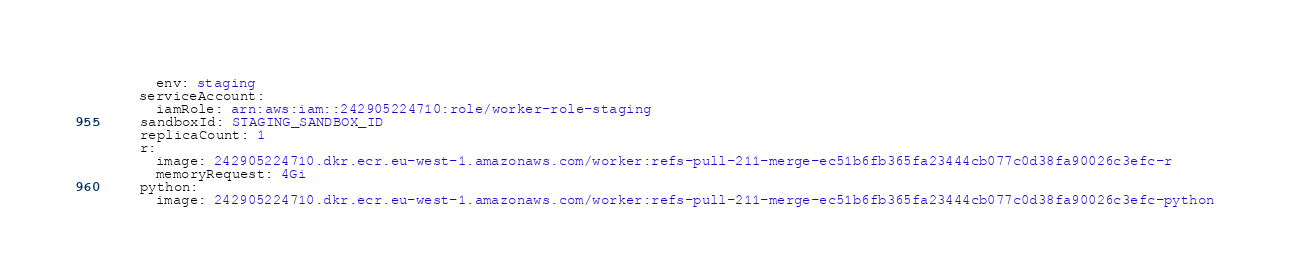Convert code to text. <code><loc_0><loc_0><loc_500><loc_500><_YAML_>      env: staging
    serviceAccount:
      iamRole: arn:aws:iam::242905224710:role/worker-role-staging
    sandboxId: STAGING_SANDBOX_ID
    replicaCount: 1
    r:
      image: 242905224710.dkr.ecr.eu-west-1.amazonaws.com/worker:refs-pull-211-merge-ec51b6fb365fa23444cb077c0d38fa90026c3efc-r
      memoryRequest: 4Gi
    python:
      image: 242905224710.dkr.ecr.eu-west-1.amazonaws.com/worker:refs-pull-211-merge-ec51b6fb365fa23444cb077c0d38fa90026c3efc-python
</code> 